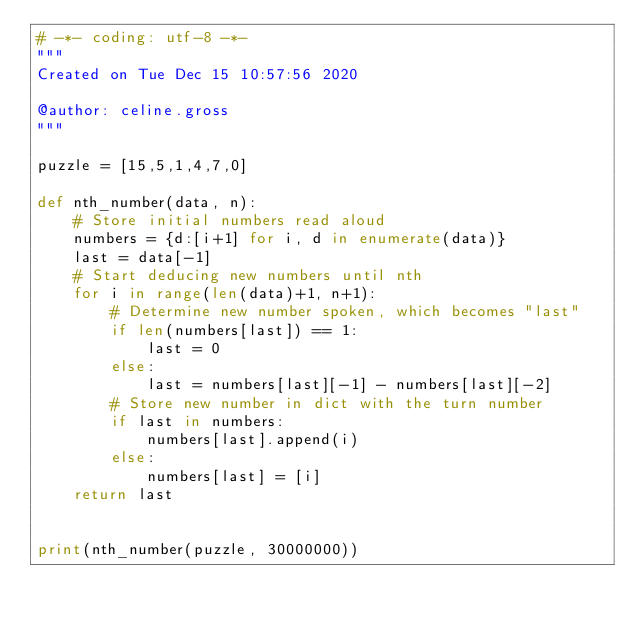Convert code to text. <code><loc_0><loc_0><loc_500><loc_500><_Python_># -*- coding: utf-8 -*-
"""
Created on Tue Dec 15 10:57:56 2020

@author: celine.gross
"""

puzzle = [15,5,1,4,7,0]

def nth_number(data, n):
    # Store initial numbers read aloud
    numbers = {d:[i+1] for i, d in enumerate(data)}
    last = data[-1]
    # Start deducing new numbers until nth
    for i in range(len(data)+1, n+1):
        # Determine new number spoken, which becomes "last"
        if len(numbers[last]) == 1:
            last = 0
        else:
            last = numbers[last][-1] - numbers[last][-2]
        # Store new number in dict with the turn number
        if last in numbers:
            numbers[last].append(i)
        else:
            numbers[last] = [i]
    return last


print(nth_number(puzzle, 30000000))    </code> 